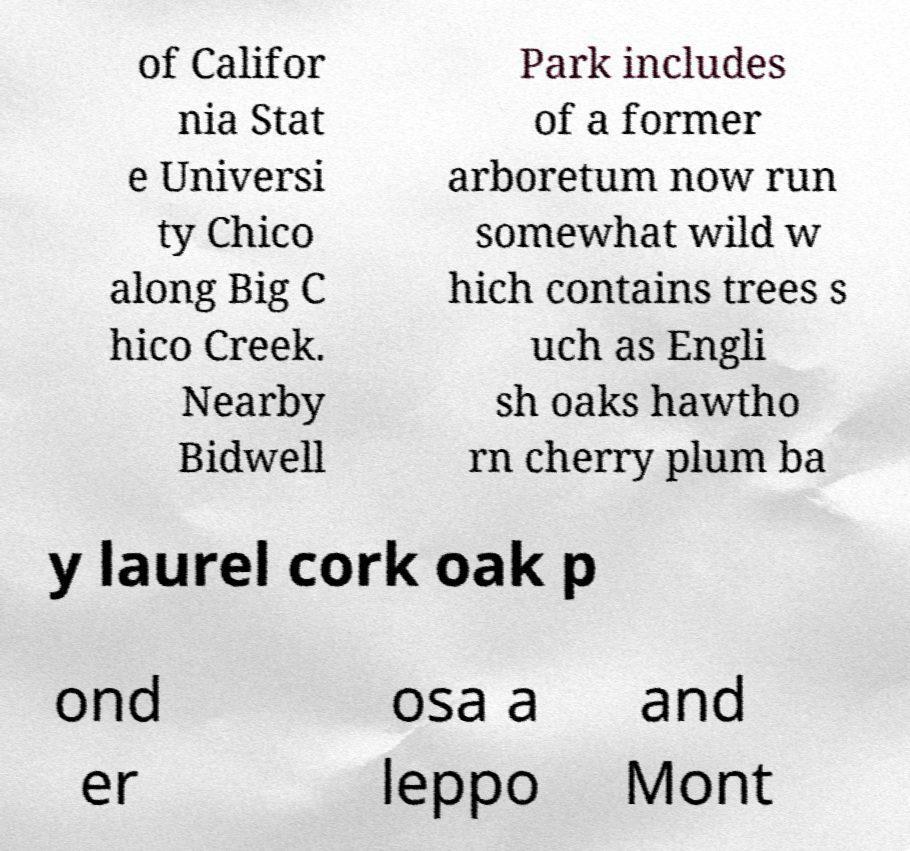Please read and relay the text visible in this image. What does it say? of Califor nia Stat e Universi ty Chico along Big C hico Creek. Nearby Bidwell Park includes of a former arboretum now run somewhat wild w hich contains trees s uch as Engli sh oaks hawtho rn cherry plum ba y laurel cork oak p ond er osa a leppo and Mont 